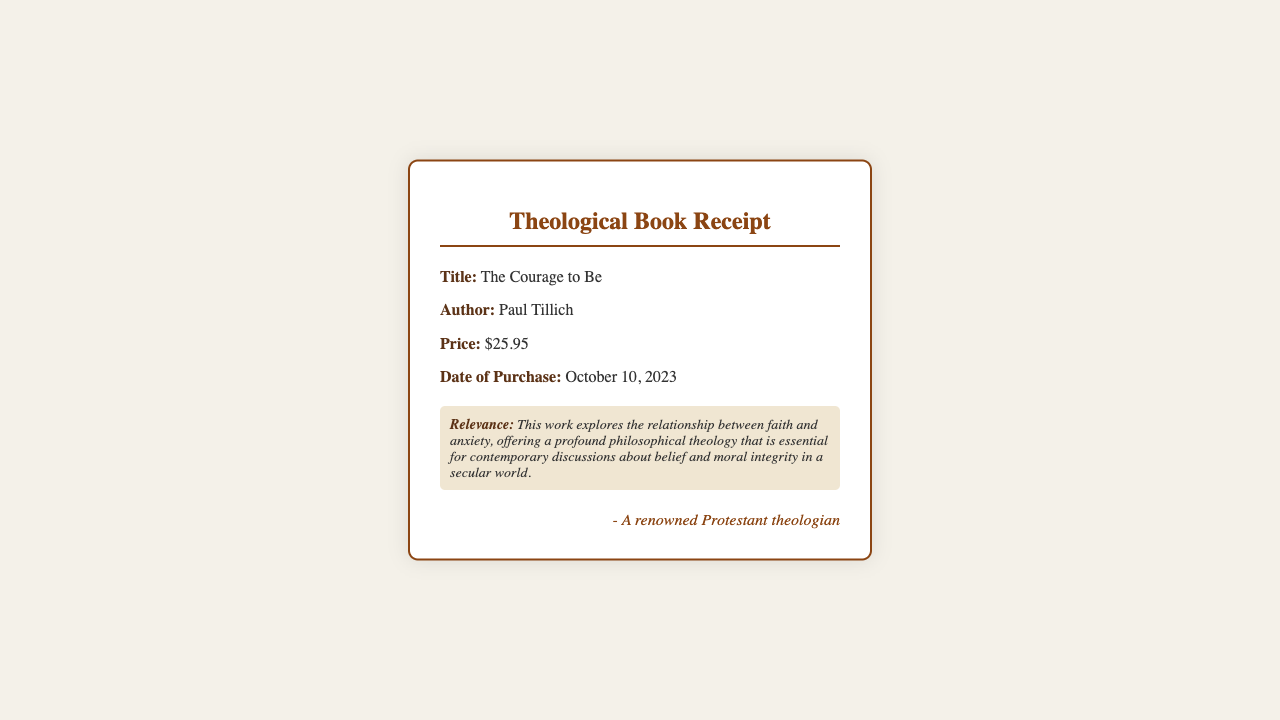What is the title of the book? The title of the book is specified under the "Title" section of the receipt.
Answer: The Courage to Be Who is the author of the book? The author of the book is mentioned next to the "Author" label on the receipt.
Answer: Paul Tillich What is the price paid for the book? The price can be found in the "Price" section of the document.
Answer: $25.95 When was the book purchased? The purchase date is indicated in the document under "Date of Purchase."
Answer: October 10, 2023 What is the relevance of the book? The relevance is described in the section labeled "Relevance" in the receipt.
Answer: This work explores the relationship between faith and anxiety, offering a profound philosophical theology that is essential for contemporary discussions about belief and moral integrity in a secular world How does the book contribute to discussions about morality? The book's exploration of the relationship between faith and anxiety suggests a significant contribution to moral discussions in a modern context.
Answer: It offers a profound philosophical theology essential for contemporary discussions about belief and moral integrity What type of document is this? The document is a receipt specifically for a theological book purchase.
Answer: Theological Book Receipt In which section would you find the purchase date? The purchase date is found under the "Date of Purchase" section of the receipt.
Answer: Date of Purchase What can you infer about the significance of the author? The author is renowned and offers insights into contemporary faith discussions, indicating his importance in theology.
Answer: Paul Tillich is a significant theologian 